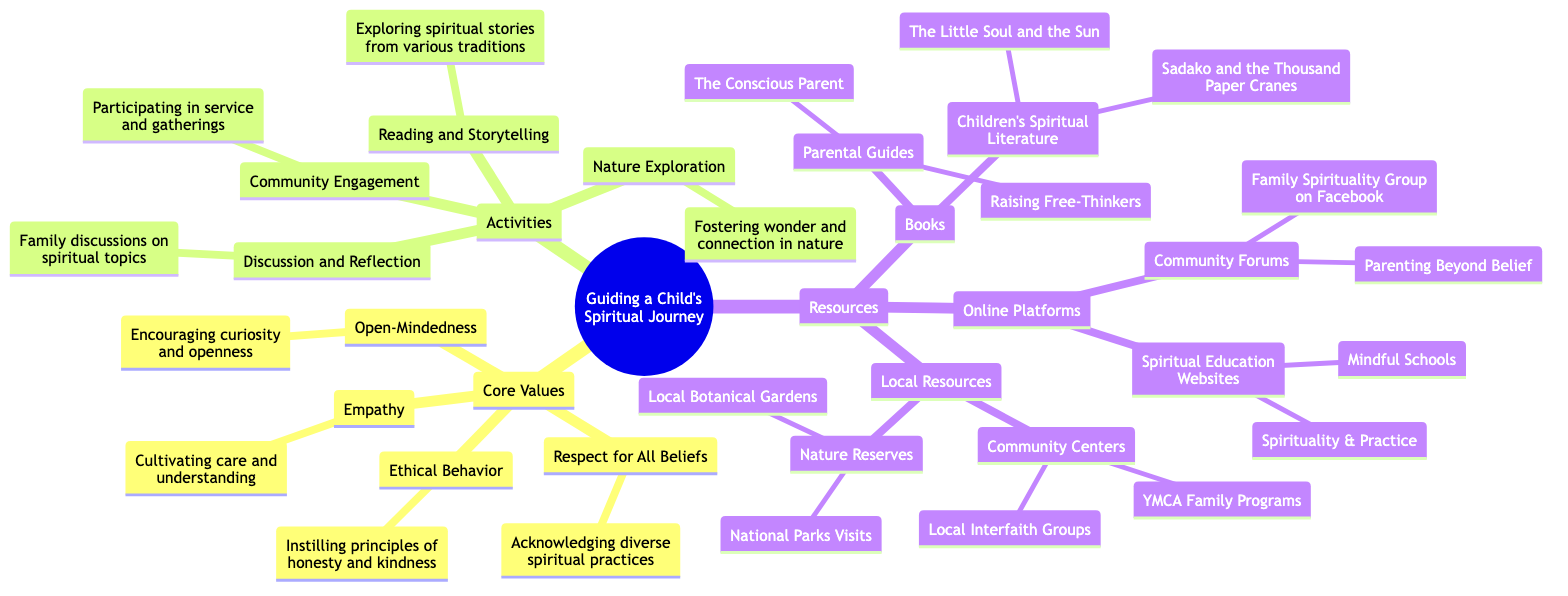What are the core values in the diagram? The diagram lists four core values: Respect for All Beliefs, Open-Mindedness, Empathy, and Ethical Behavior.
Answer: Respect for All Beliefs, Open-Mindedness, Empathy, Ethical Behavior How many activities are outlined in the diagram? The diagram shows four main activities: Discussion and Reflection, Reading and Storytelling, Community Engagement, and Nature Exploration. Therefore, the total number is four.
Answer: 4 What is the first book listed under Children's Spiritual Literature? The first book mentioned under Children's Spiritual Literature in the diagram is "The Little Soul and the Sun."
Answer: The Little Soul and the Sun What resources are categorized under Local Resources? Local Resources in the diagram include Community Centers (like YMCA Family Programs and Local Interfaith Groups) and Nature Reserves (like National Parks Visits and Local Botanical Gardens).
Answer: Community Centers, Nature Reserves Which value emphasizes understanding others' experiences? Empathy is the value that emphasizes cultivating care and understanding for others' experiences, as described in the diagram.
Answer: Empathy How does Community Engagement relate to other activities? Community Engagement is one of the four key activities highlighted in the diagram, and it relates closely to engaging with others through service and gatherings, connecting it to the values of empathy and ethical behavior.
Answer: Community Engagement What type of online platforms are listed? The diagram specifies two types of online platforms: Spiritual Education Websites (like Mindful Schools and Spirituality & Practice) and Community Forums (like Parenting Beyond Belief and Family Spirituality Group on Facebook).
Answer: Spiritual Education Websites, Community Forums Which activity is associated with fostering a sense of wonder? Nature Exploration is the activity associated with fostering a sense of wonder and connection by spending time in nature, as indicated in the diagram.
Answer: Nature Exploration What principles does Ethical Behavior instill? Ethical Behavior instills principles of honesty, integrity, and kindness, which are directly outlined in the diagram under Core Values.
Answer: Honesty, integrity, kindness 